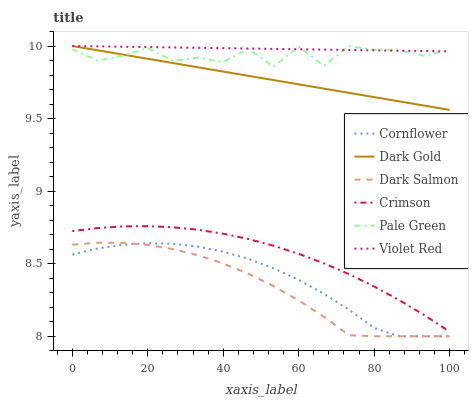Does Dark Salmon have the minimum area under the curve?
Answer yes or no. Yes. Does Violet Red have the maximum area under the curve?
Answer yes or no. Yes. Does Dark Gold have the minimum area under the curve?
Answer yes or no. No. Does Dark Gold have the maximum area under the curve?
Answer yes or no. No. Is Dark Gold the smoothest?
Answer yes or no. Yes. Is Pale Green the roughest?
Answer yes or no. Yes. Is Violet Red the smoothest?
Answer yes or no. No. Is Violet Red the roughest?
Answer yes or no. No. Does Dark Gold have the lowest value?
Answer yes or no. No. Does Pale Green have the highest value?
Answer yes or no. Yes. Does Dark Salmon have the highest value?
Answer yes or no. No. Is Cornflower less than Pale Green?
Answer yes or no. Yes. Is Violet Red greater than Dark Salmon?
Answer yes or no. Yes. Does Pale Green intersect Violet Red?
Answer yes or no. Yes. Is Pale Green less than Violet Red?
Answer yes or no. No. Is Pale Green greater than Violet Red?
Answer yes or no. No. Does Cornflower intersect Pale Green?
Answer yes or no. No. 